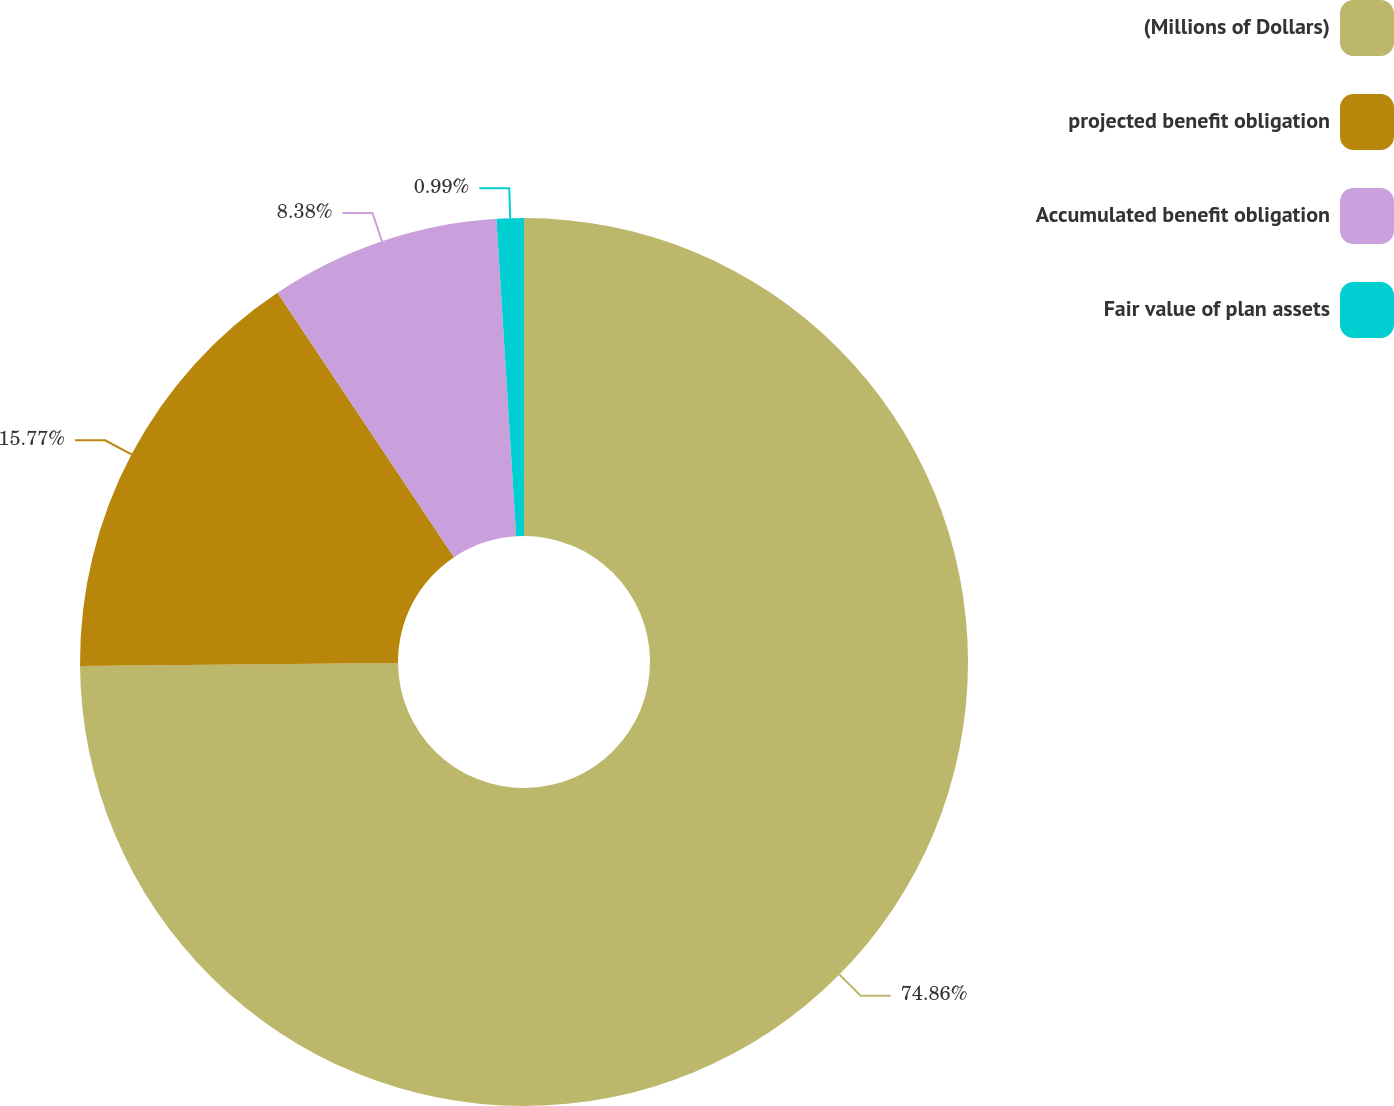<chart> <loc_0><loc_0><loc_500><loc_500><pie_chart><fcel>(Millions of Dollars)<fcel>projected benefit obligation<fcel>Accumulated benefit obligation<fcel>Fair value of plan assets<nl><fcel>74.86%<fcel>15.77%<fcel>8.38%<fcel>0.99%<nl></chart> 